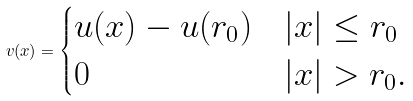<formula> <loc_0><loc_0><loc_500><loc_500>v ( x ) = \begin{cases} u ( x ) - u ( r _ { 0 } ) & | x | \leq r _ { 0 } \\ 0 & | x | > r _ { 0 } . \end{cases}</formula> 